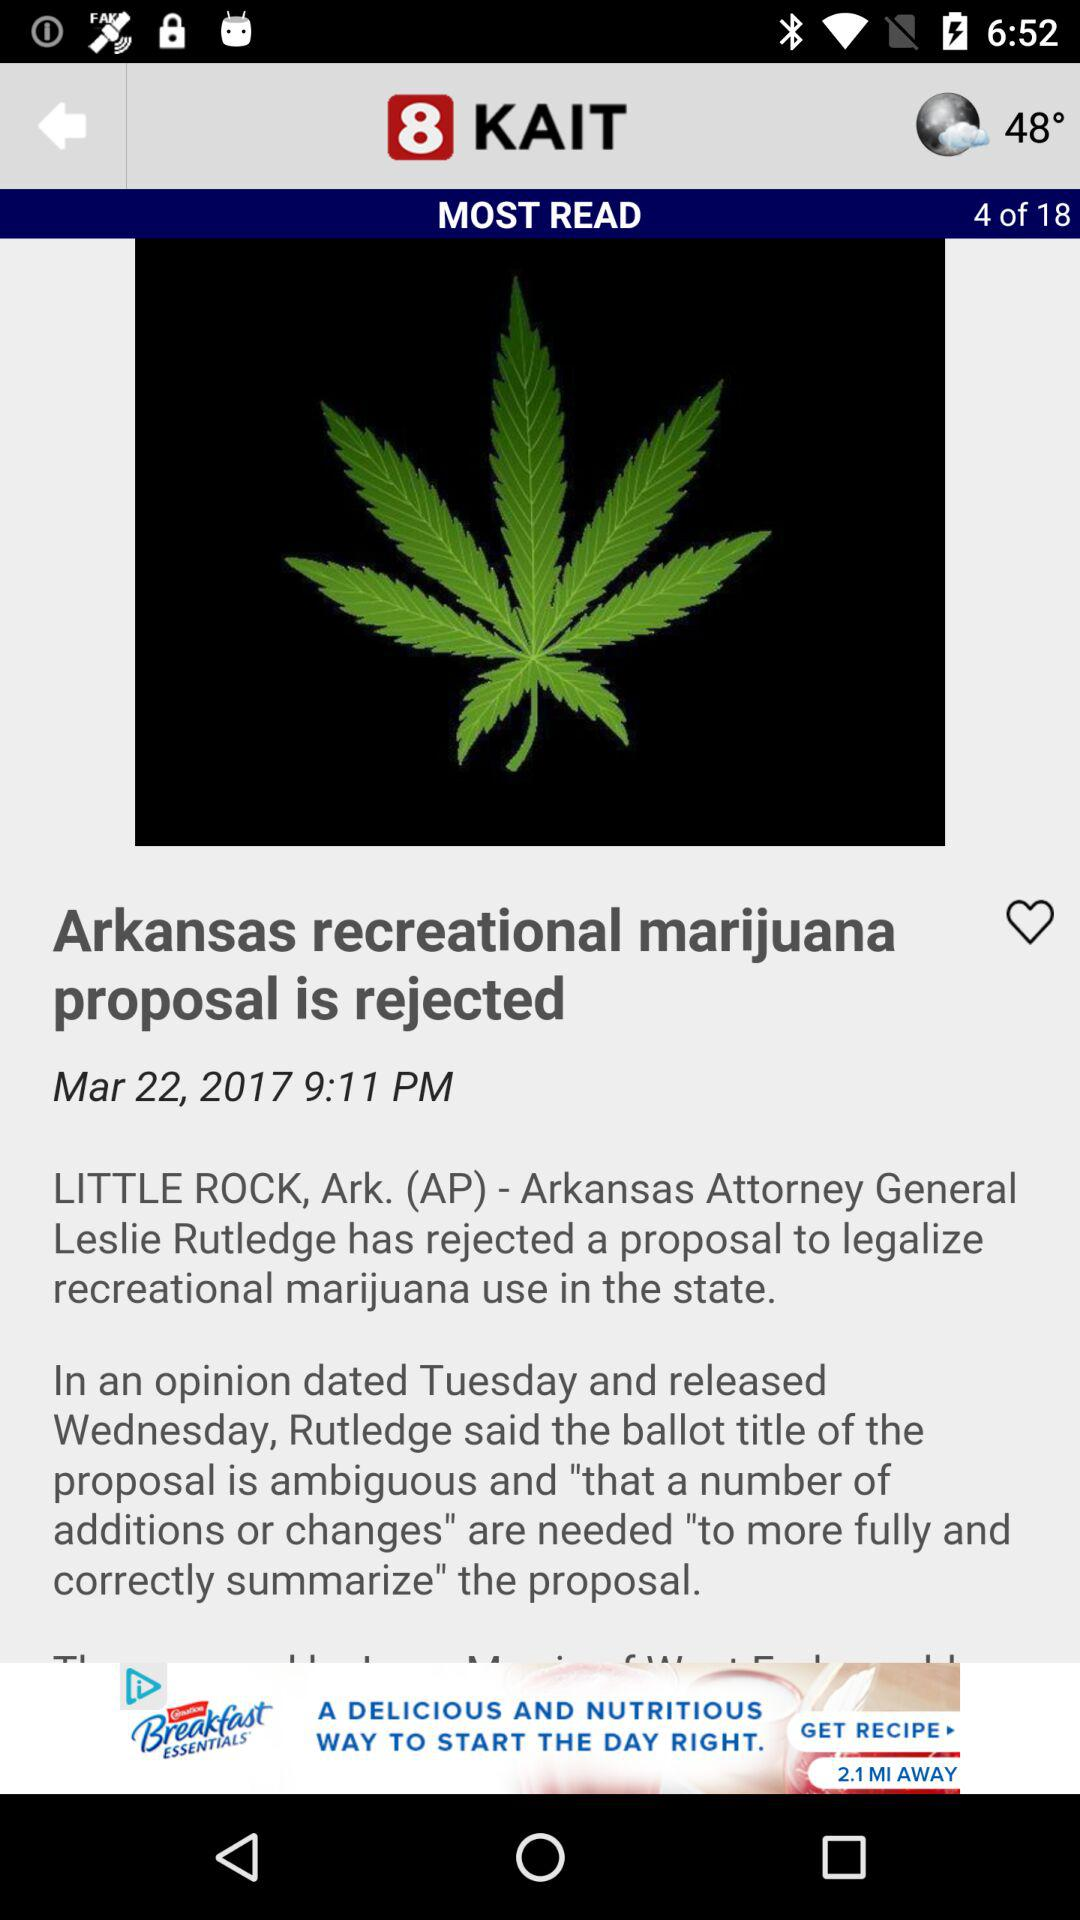How much petrosal is left?
When the provided information is insufficient, respond with <no answer>. <no answer> 